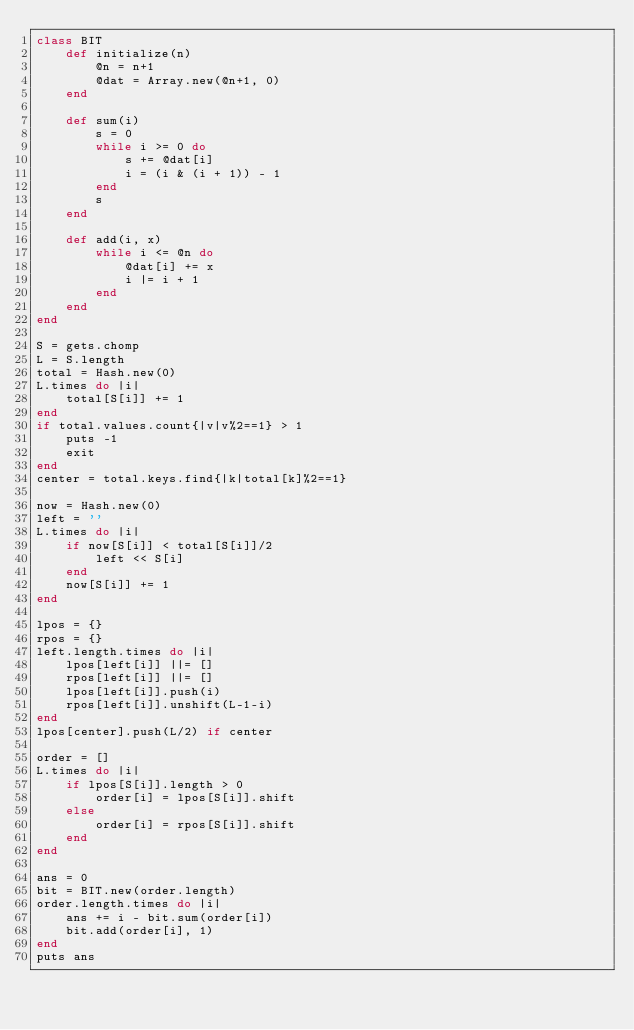<code> <loc_0><loc_0><loc_500><loc_500><_Ruby_>class BIT
    def initialize(n)
        @n = n+1
        @dat = Array.new(@n+1, 0)
    end

    def sum(i)
        s = 0
        while i >= 0 do
            s += @dat[i]
            i = (i & (i + 1)) - 1
        end
        s
    end

    def add(i, x)
        while i <= @n do
            @dat[i] += x
            i |= i + 1
        end
    end
end

S = gets.chomp
L = S.length
total = Hash.new(0)
L.times do |i|
    total[S[i]] += 1
end
if total.values.count{|v|v%2==1} > 1
    puts -1
    exit
end
center = total.keys.find{|k|total[k]%2==1}

now = Hash.new(0)
left = ''
L.times do |i|
    if now[S[i]] < total[S[i]]/2
        left << S[i]
    end
    now[S[i]] += 1
end

lpos = {}
rpos = {}
left.length.times do |i|
    lpos[left[i]] ||= []
    rpos[left[i]] ||= []
    lpos[left[i]].push(i)
    rpos[left[i]].unshift(L-1-i)
end
lpos[center].push(L/2) if center

order = []
L.times do |i|
    if lpos[S[i]].length > 0
        order[i] = lpos[S[i]].shift
    else
        order[i] = rpos[S[i]].shift
    end
end

ans = 0
bit = BIT.new(order.length)
order.length.times do |i|
    ans += i - bit.sum(order[i])
    bit.add(order[i], 1)
end
puts ans</code> 